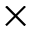Convert formula to latex. <formula><loc_0><loc_0><loc_500><loc_500>\times</formula> 